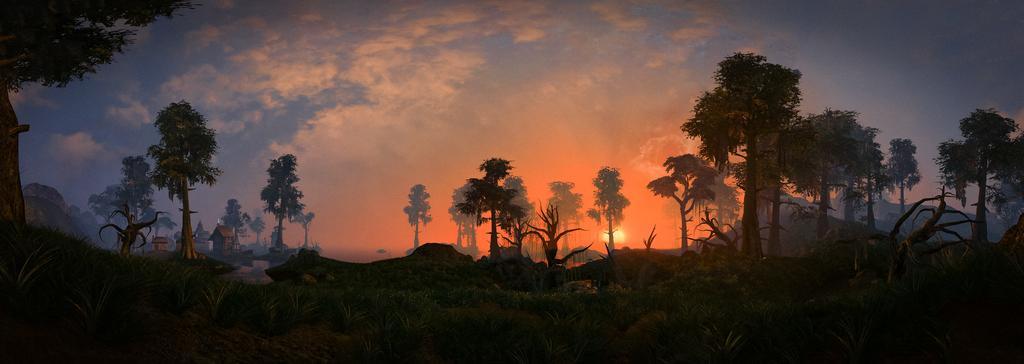Please provide a concise description of this image. In this image, we can see so many trees, plants, houses. Background there is a sky. 